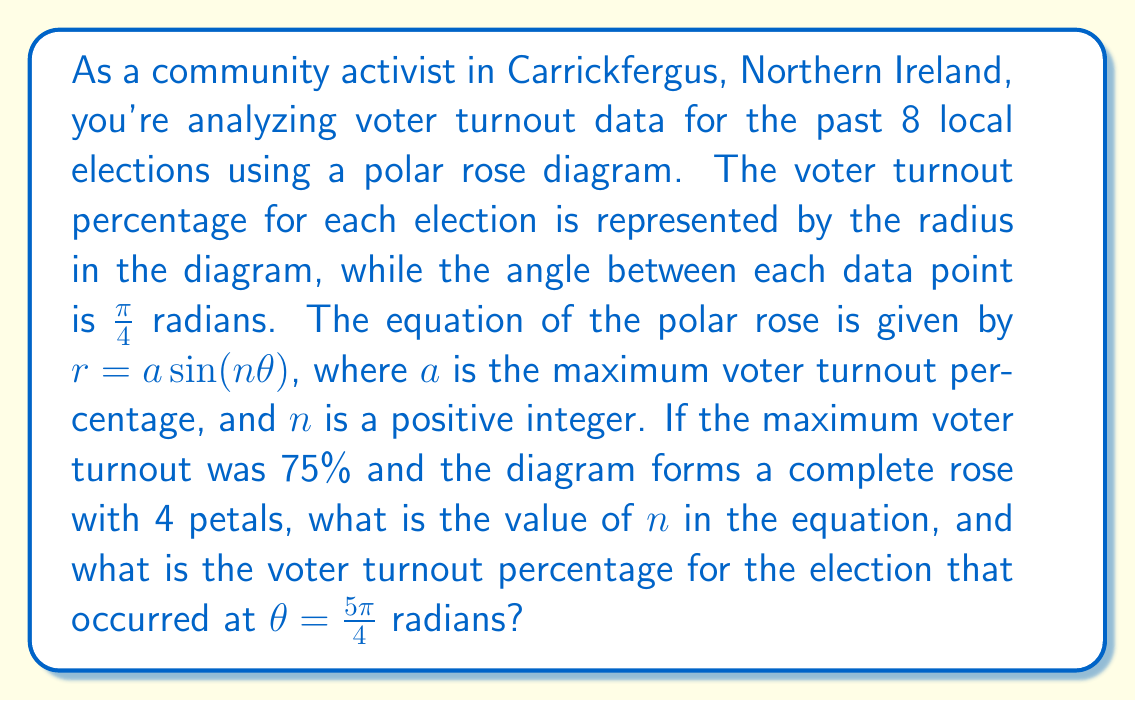Teach me how to tackle this problem. Let's approach this step-by-step:

1) For a polar rose with 4 petals, we need $n = 4$ in the equation $r = a \sin(n\theta)$. This is because the number of petals in a polar rose is equal to $n$ when $n$ is even.

2) The equation of our polar rose is therefore:

   $r = 75 \sin(4\theta)$

3) To find the voter turnout at $\theta = \frac{5\pi}{4}$, we substitute this value into our equation:

   $r = 75 \sin(4 \cdot \frac{5\pi}{4})$

4) Simplify inside the parentheses:

   $r = 75 \sin(5\pi)$

5) Recall that $\sin(5\pi) = 0$, so:

   $r = 75 \cdot 0 = 0$

6) This means that at $\theta = \frac{5\pi}{4}$, the voter turnout was 0%.

To visualize this, we can consider that in a 4-petal rose, the petals occur at multiples of $\frac{\pi}{2}$, and the points where $r = 0$ occur halfway between these, at odd multiples of $\frac{\pi}{4}$. $\frac{5\pi}{4}$ is one such point.
Answer: The value of $n$ in the equation is 4, and the voter turnout percentage for the election that occurred at $\theta = \frac{5\pi}{4}$ radians is 0%. 